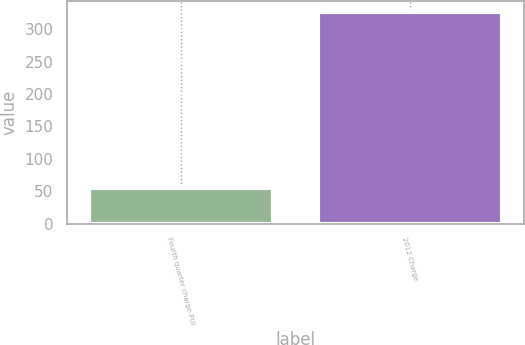<chart> <loc_0><loc_0><loc_500><loc_500><bar_chart><fcel>Fourth quarter charge-PUI<fcel>2012 Charge<nl><fcel>54.6<fcel>327.4<nl></chart> 